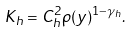<formula> <loc_0><loc_0><loc_500><loc_500>K _ { h } = C _ { h } ^ { 2 } \rho ( y ) ^ { 1 - \gamma _ { h } } .</formula> 